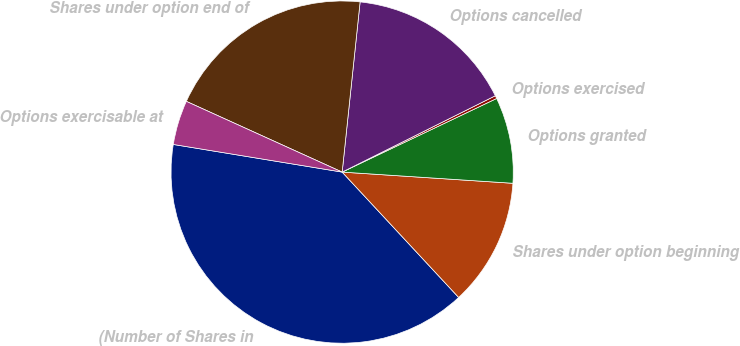<chart> <loc_0><loc_0><loc_500><loc_500><pie_chart><fcel>(Number of Shares in<fcel>Shares under option beginning<fcel>Options granted<fcel>Options exercised<fcel>Options cancelled<fcel>Shares under option end of<fcel>Options exercisable at<nl><fcel>39.5%<fcel>12.04%<fcel>8.12%<fcel>0.28%<fcel>15.97%<fcel>19.89%<fcel>4.2%<nl></chart> 